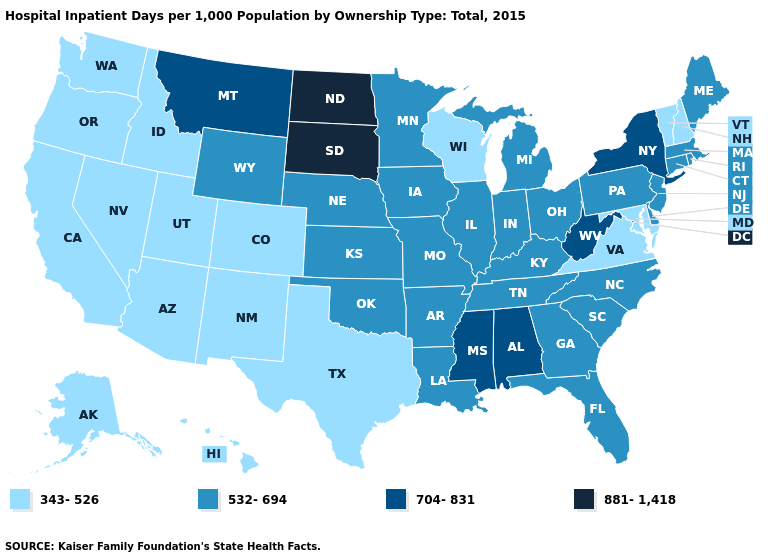Does the first symbol in the legend represent the smallest category?
Quick response, please. Yes. Name the states that have a value in the range 704-831?
Answer briefly. Alabama, Mississippi, Montana, New York, West Virginia. Which states have the highest value in the USA?
Answer briefly. North Dakota, South Dakota. What is the lowest value in states that border Mississippi?
Keep it brief. 532-694. Name the states that have a value in the range 343-526?
Write a very short answer. Alaska, Arizona, California, Colorado, Hawaii, Idaho, Maryland, Nevada, New Hampshire, New Mexico, Oregon, Texas, Utah, Vermont, Virginia, Washington, Wisconsin. What is the value of Kentucky?
Write a very short answer. 532-694. What is the highest value in states that border Iowa?
Concise answer only. 881-1,418. Name the states that have a value in the range 704-831?
Short answer required. Alabama, Mississippi, Montana, New York, West Virginia. Does New York have the lowest value in the USA?
Concise answer only. No. Name the states that have a value in the range 704-831?
Write a very short answer. Alabama, Mississippi, Montana, New York, West Virginia. Does Massachusetts have a lower value than Mississippi?
Answer briefly. Yes. Which states have the lowest value in the USA?
Concise answer only. Alaska, Arizona, California, Colorado, Hawaii, Idaho, Maryland, Nevada, New Hampshire, New Mexico, Oregon, Texas, Utah, Vermont, Virginia, Washington, Wisconsin. What is the highest value in the South ?
Quick response, please. 704-831. What is the highest value in the Northeast ?
Be succinct. 704-831. Name the states that have a value in the range 532-694?
Give a very brief answer. Arkansas, Connecticut, Delaware, Florida, Georgia, Illinois, Indiana, Iowa, Kansas, Kentucky, Louisiana, Maine, Massachusetts, Michigan, Minnesota, Missouri, Nebraska, New Jersey, North Carolina, Ohio, Oklahoma, Pennsylvania, Rhode Island, South Carolina, Tennessee, Wyoming. 